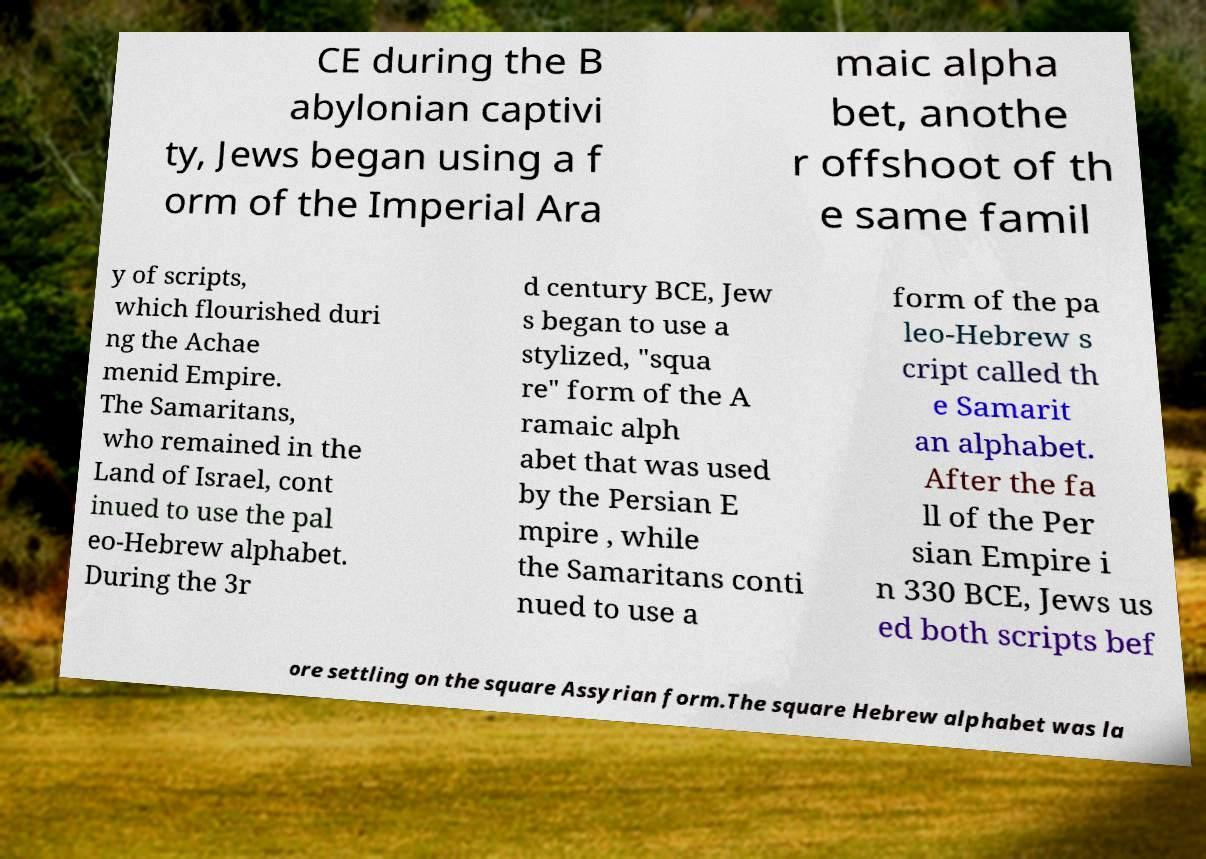I need the written content from this picture converted into text. Can you do that? CE during the B abylonian captivi ty, Jews began using a f orm of the Imperial Ara maic alpha bet, anothe r offshoot of th e same famil y of scripts, which flourished duri ng the Achae menid Empire. The Samaritans, who remained in the Land of Israel, cont inued to use the pal eo-Hebrew alphabet. During the 3r d century BCE, Jew s began to use a stylized, "squa re" form of the A ramaic alph abet that was used by the Persian E mpire , while the Samaritans conti nued to use a form of the pa leo-Hebrew s cript called th e Samarit an alphabet. After the fa ll of the Per sian Empire i n 330 BCE, Jews us ed both scripts bef ore settling on the square Assyrian form.The square Hebrew alphabet was la 